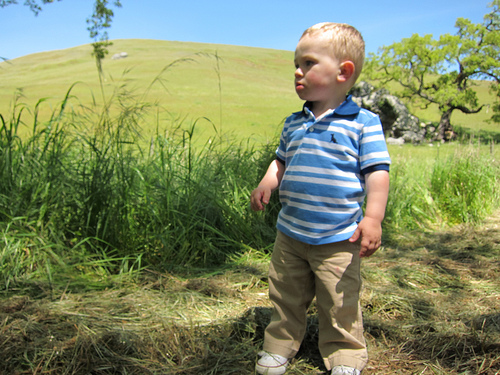<image>
Is the boy on the hill? No. The boy is not positioned on the hill. They may be near each other, but the boy is not supported by or resting on top of the hill. Is the hill to the left of the boy? No. The hill is not to the left of the boy. From this viewpoint, they have a different horizontal relationship. Where is the tree in relation to the boy? Is it behind the boy? Yes. From this viewpoint, the tree is positioned behind the boy, with the boy partially or fully occluding the tree. Where is the boy in relation to the plant? Is it behind the plant? No. The boy is not behind the plant. From this viewpoint, the boy appears to be positioned elsewhere in the scene. 